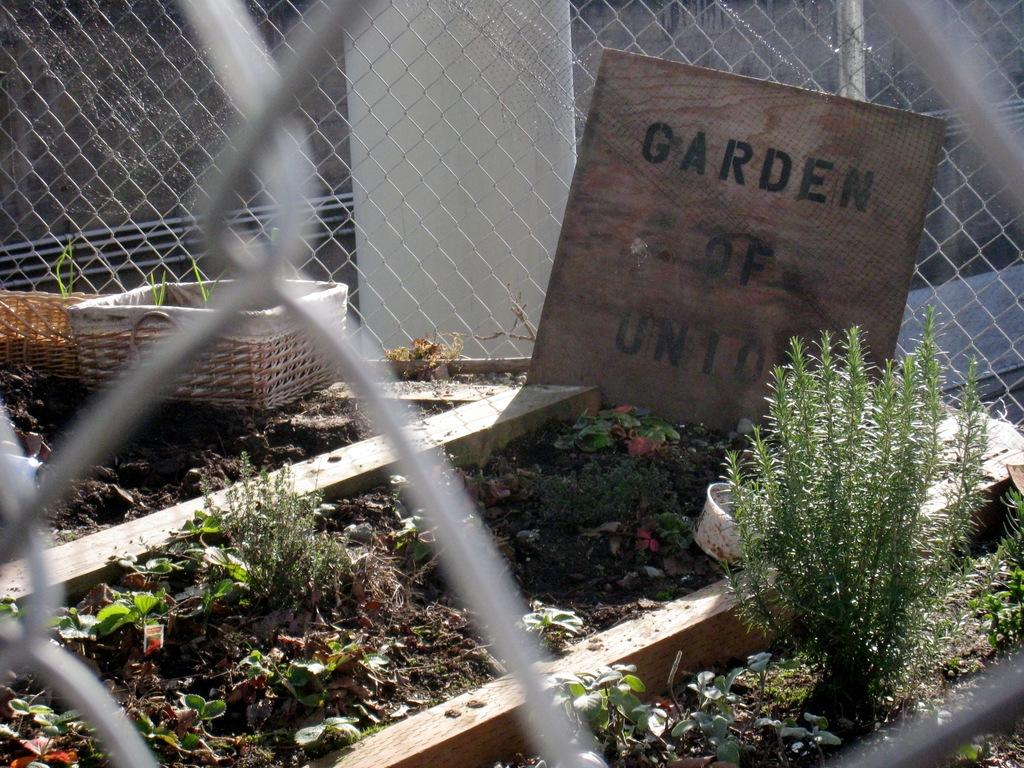What is the main object in the image? There is a board in the image. What is on the board? Something is written on the board. What else can be seen in the image besides the board? There is a basket and small plants visible in the image. What is in the background of the image? There is an iron net visible in the background of the image. Can you see a bee buzzing around the chin of the person in the image? There is no person or bee present in the image. What type of plot is being discussed on the board in the image? The image does not show any plot being discussed; it only shows something written on the board. 